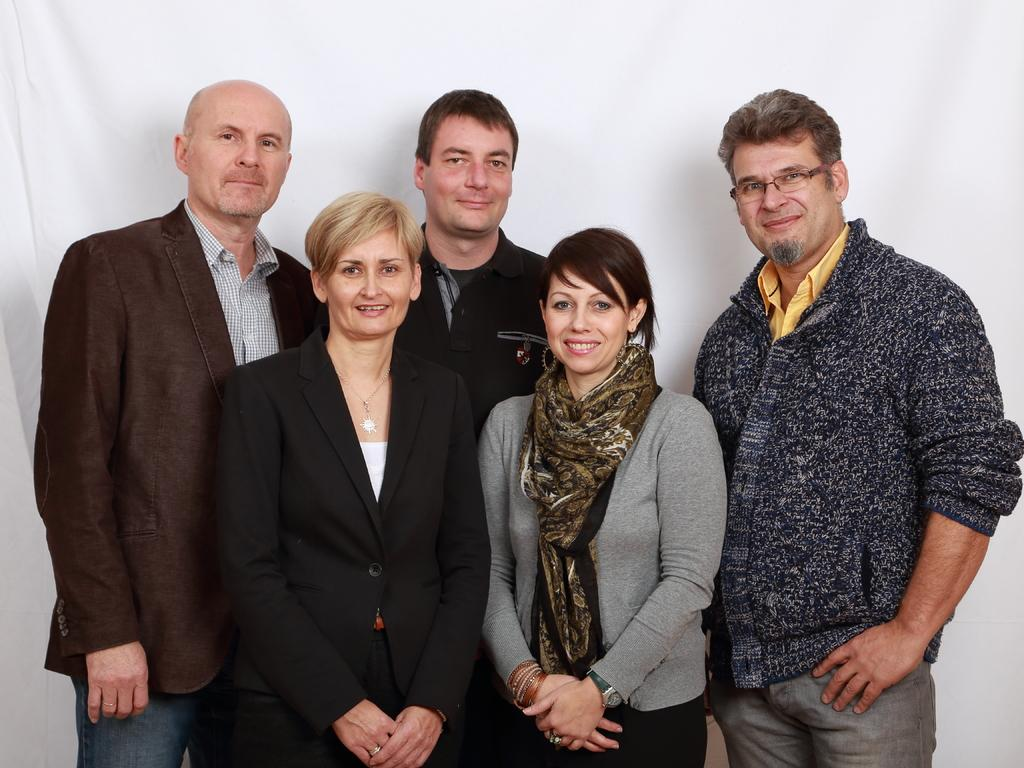How many people are present in the image? There are five people in the image, three men and two women. Can you describe the background of the image? There is a white cloth in the background of the image. What type of boundary can be seen in the image? There is no boundary present in the image. How many times do the women sneeze in the image? There is no indication of anyone sneezing in the image. 